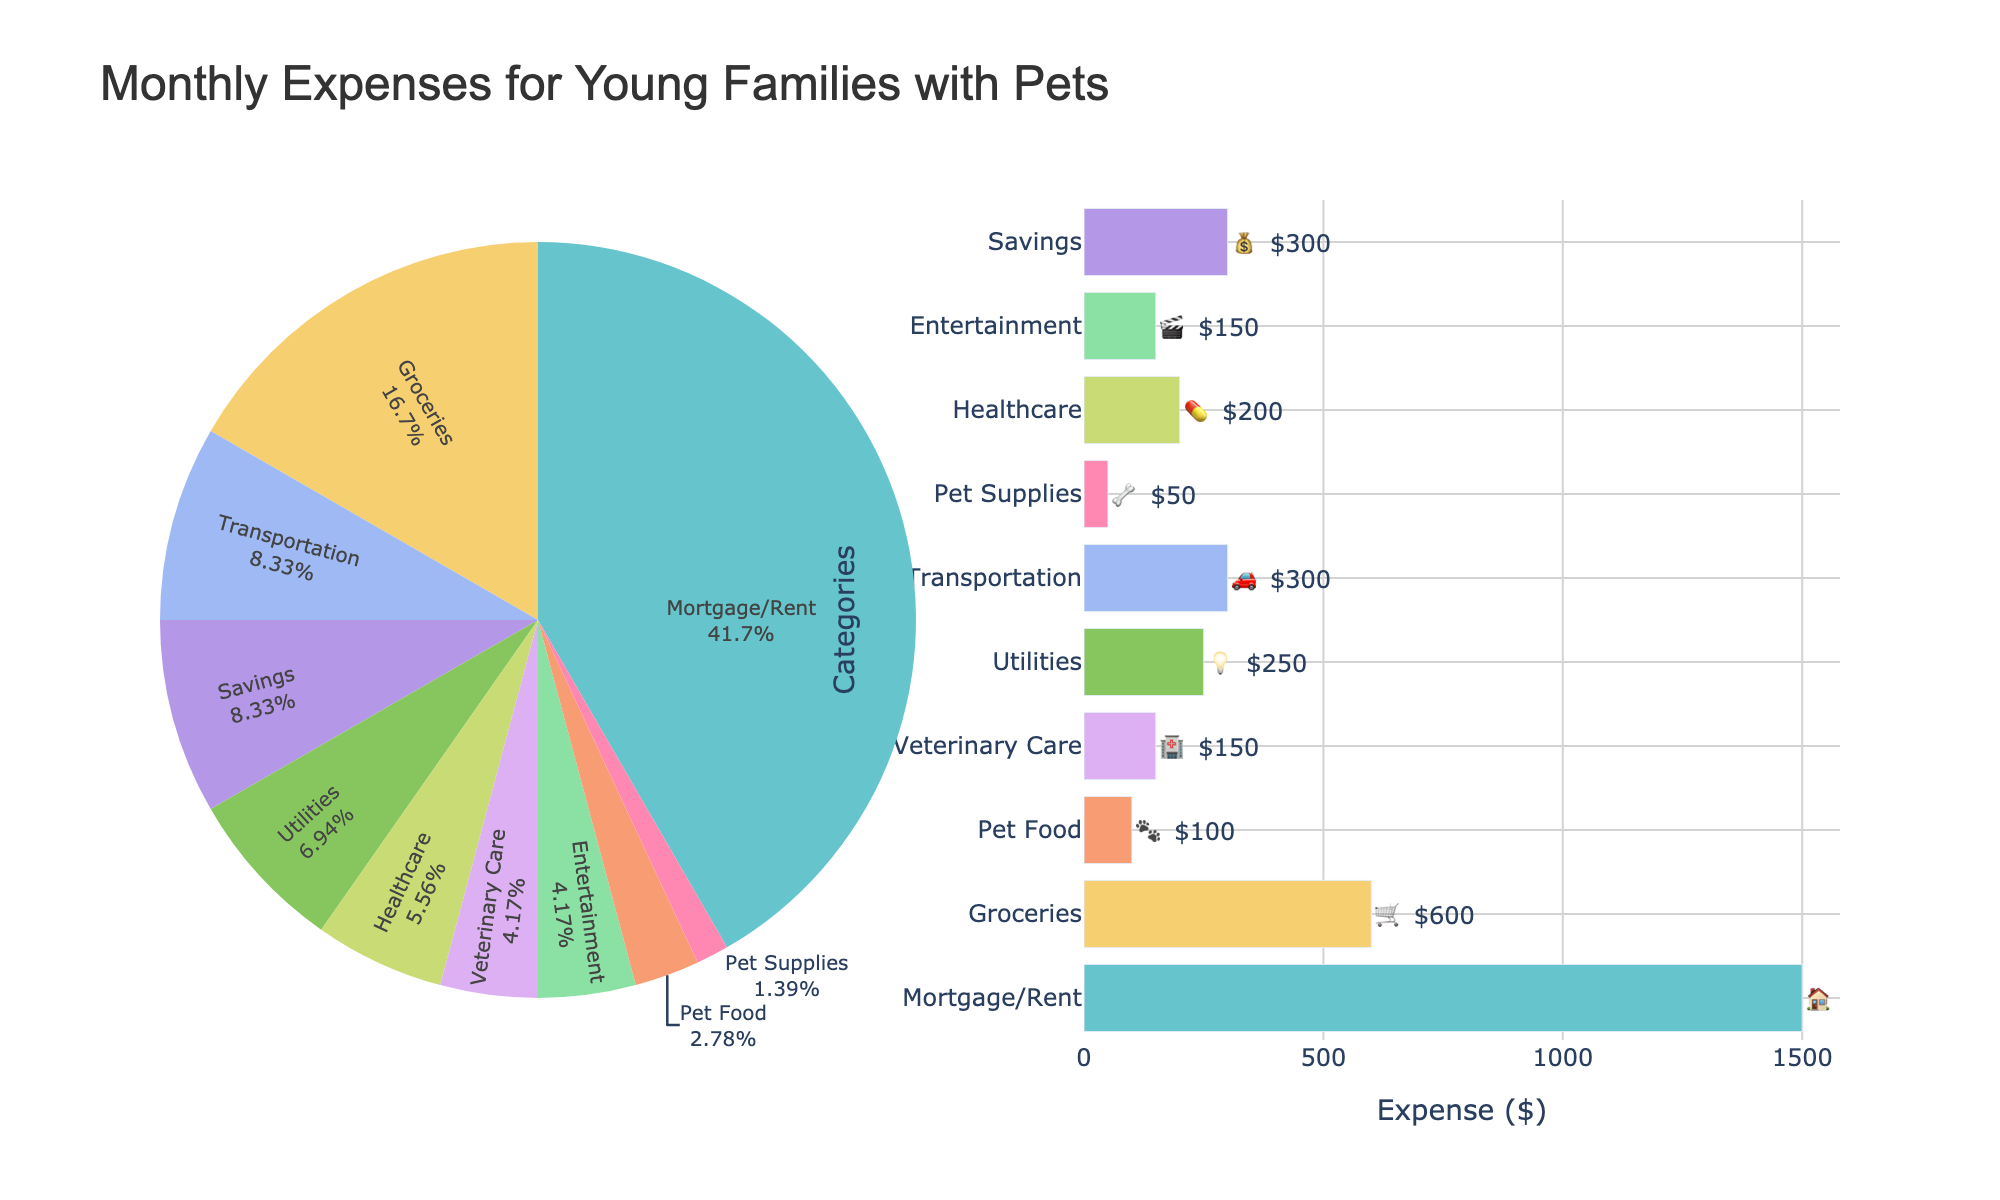What's the largest expense category? The largest expense category can be identified by looking at either the pie chart or the bar chart. In both charts, the "Mortgage/Rent" category has the highest value.
Answer: Mortgage/Rent What percentage of the total expenses is spent on groceries? In the pie chart, each category's portion of the total expense is visible as a percentage. The "Groceries" category shows its percentage directly on the pie chart.
Answer: 25% Which has a higher expense: Veterinary Care or Pet Supplies? To compare these two categories, look at the bar chart. The bar representing "Veterinary Care" is longer than the bar for "Pet Supplies," indicating a higher expense.
Answer: Veterinary Care What is the combined expense for both Pet Food and Pet Supplies? To find the combined expense, add the expenses for "Pet Food" and "Pet Supplies." Pet Food is $100, and Pet Supplies is $50. So, $100 + $50.
Answer: $150 Is Transportation expense less than Utilities expense? Compare the bar lengths for "Transportation" and "Utilities" in the bar chart. The bar for "Transportation" is longer than for "Utilities," indicating that Transportation expenses are not less.
Answer: No What is the total expense for Healthcare and Entertainment combined? Sum the values for both categories. Healthcare is $200, and Entertainment is $150. $200 + $150 equals the combined total.
Answer: $350 How much more is spent on Mortgage/Rent than on Savings? Subtract the expense for Savings from the expense for Mortgage/Rent. Mortgage/Rent is $1500, and Savings is $300. $1500 - $300.
Answer: $1200 What category has the smallest expense? The bar chart shows the category with the shortest bar, which represents the smallest expense. Pet Supplies has the shortest bar.
Answer: Pet Supplies Which expense is closest to $300? Look at the bar chart to find the bar that is closest to the $300 mark. Both Transportation and Savings are exactly $300.
Answer: Transportation and Savings How much is the total monthly expense for the family? Sum all of the expenses listed across the categories. Mortgage/Rent ($1500), Groceries ($600), Pet Food ($100), Veterinary Care ($150), Utilities ($250), Transportation ($300), Pet Supplies ($50), Healthcare ($200), Entertainment ($150), and Savings ($300). The total is $3600.
Answer: $3600 